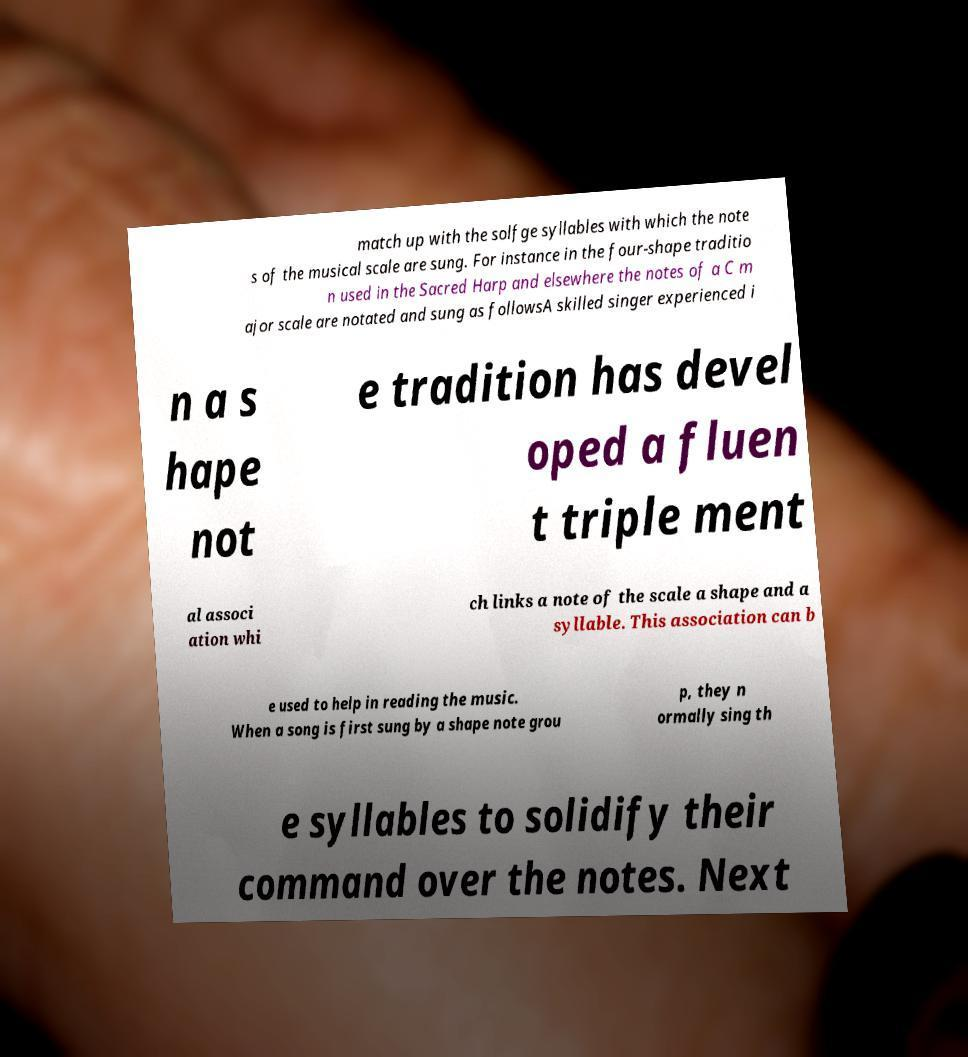There's text embedded in this image that I need extracted. Can you transcribe it verbatim? match up with the solfge syllables with which the note s of the musical scale are sung. For instance in the four-shape traditio n used in the Sacred Harp and elsewhere the notes of a C m ajor scale are notated and sung as followsA skilled singer experienced i n a s hape not e tradition has devel oped a fluen t triple ment al associ ation whi ch links a note of the scale a shape and a syllable. This association can b e used to help in reading the music. When a song is first sung by a shape note grou p, they n ormally sing th e syllables to solidify their command over the notes. Next 